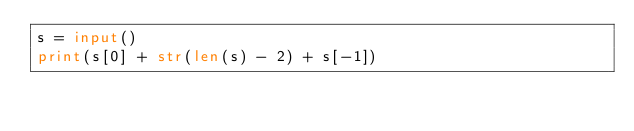<code> <loc_0><loc_0><loc_500><loc_500><_Python_>s = input()
print(s[0] + str(len(s) - 2) + s[-1])</code> 